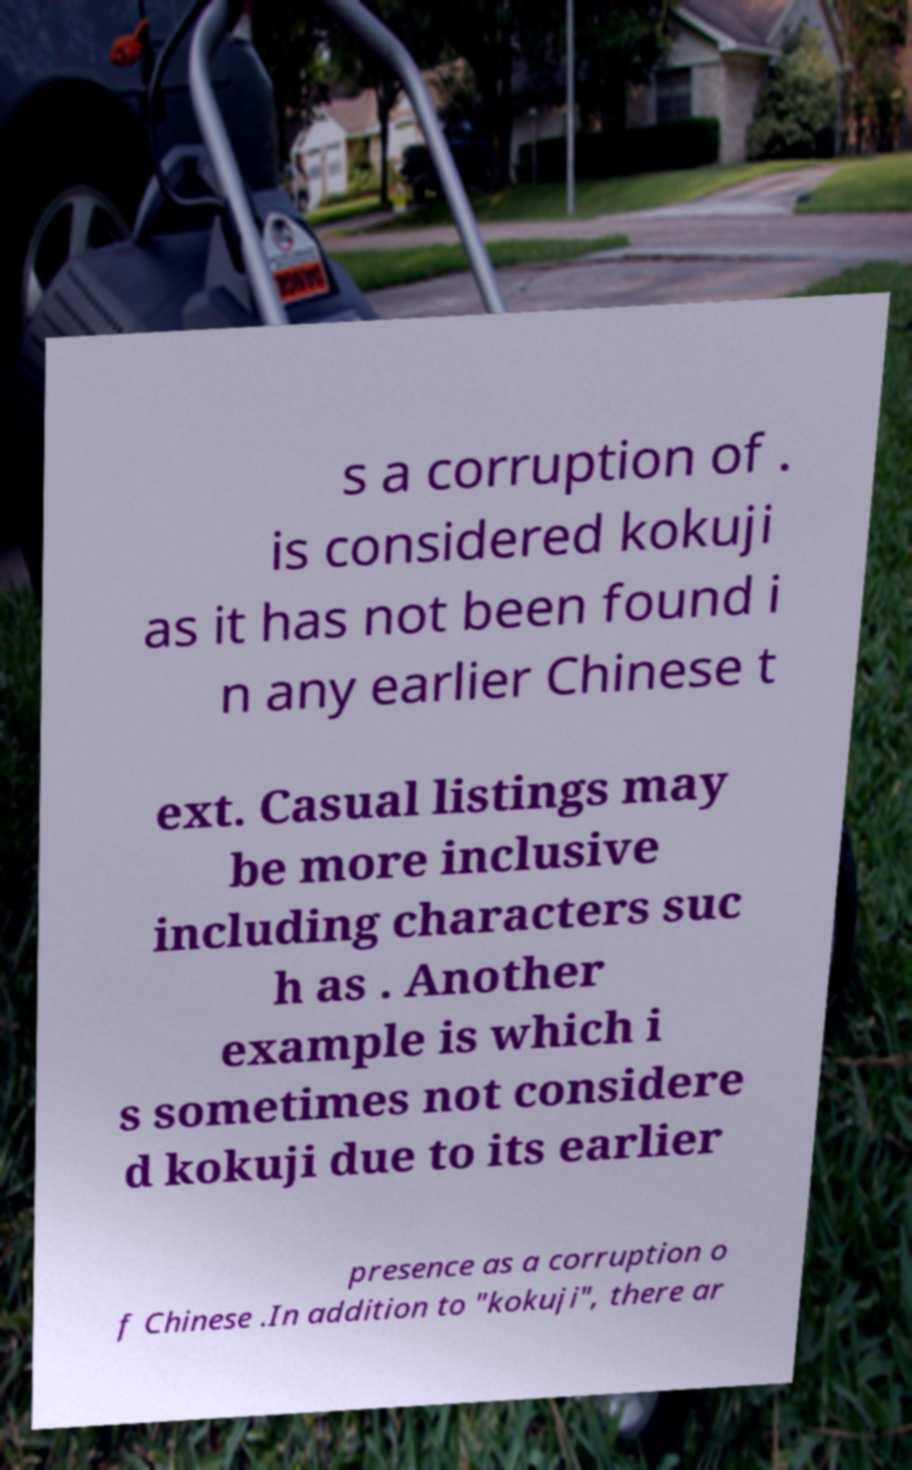Please identify and transcribe the text found in this image. s a corruption of . is considered kokuji as it has not been found i n any earlier Chinese t ext. Casual listings may be more inclusive including characters suc h as . Another example is which i s sometimes not considere d kokuji due to its earlier presence as a corruption o f Chinese .In addition to "kokuji", there ar 